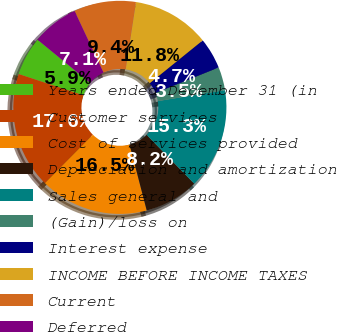Convert chart to OTSL. <chart><loc_0><loc_0><loc_500><loc_500><pie_chart><fcel>Years ended December 31 (in<fcel>Customer services<fcel>Cost of services provided<fcel>Depreciation and amortization<fcel>Sales general and<fcel>(Gain)/loss on<fcel>Interest expense<fcel>INCOME BEFORE INCOME TAXES<fcel>Current<fcel>Deferred<nl><fcel>5.88%<fcel>17.65%<fcel>16.47%<fcel>8.24%<fcel>15.29%<fcel>3.53%<fcel>4.71%<fcel>11.76%<fcel>9.41%<fcel>7.06%<nl></chart> 